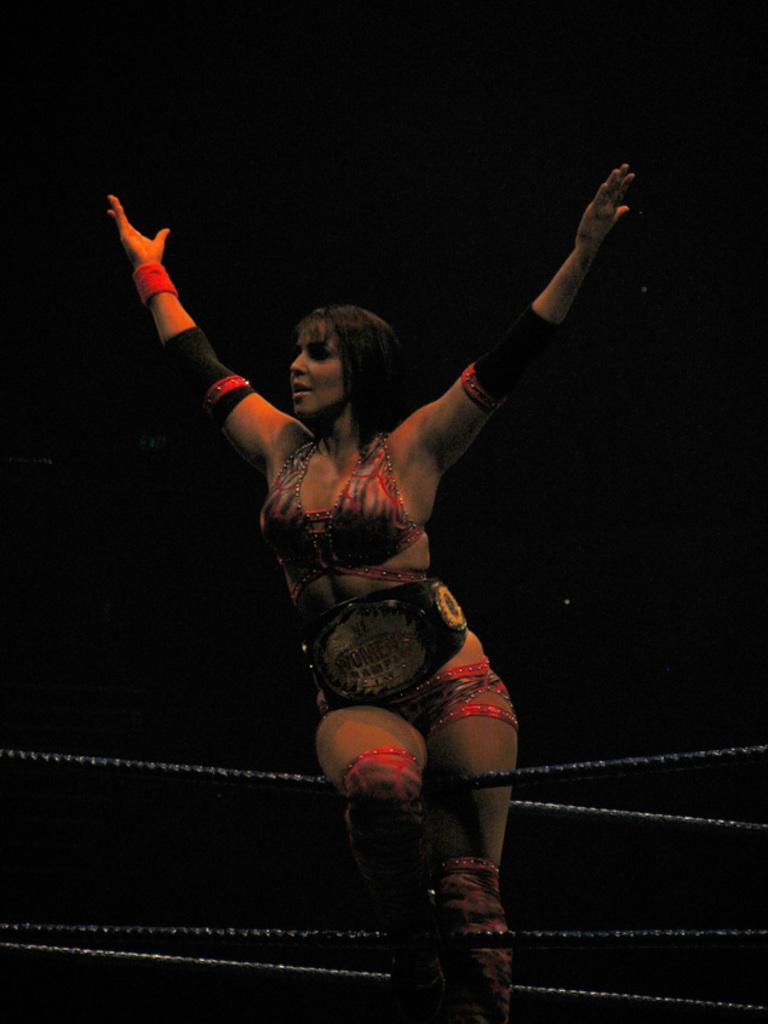Can you describe this image briefly? In this image we can see there is a person standing and there are ropes. And there is a dark background. 